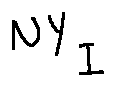<formula> <loc_0><loc_0><loc_500><loc_500>N Y _ { I }</formula> 